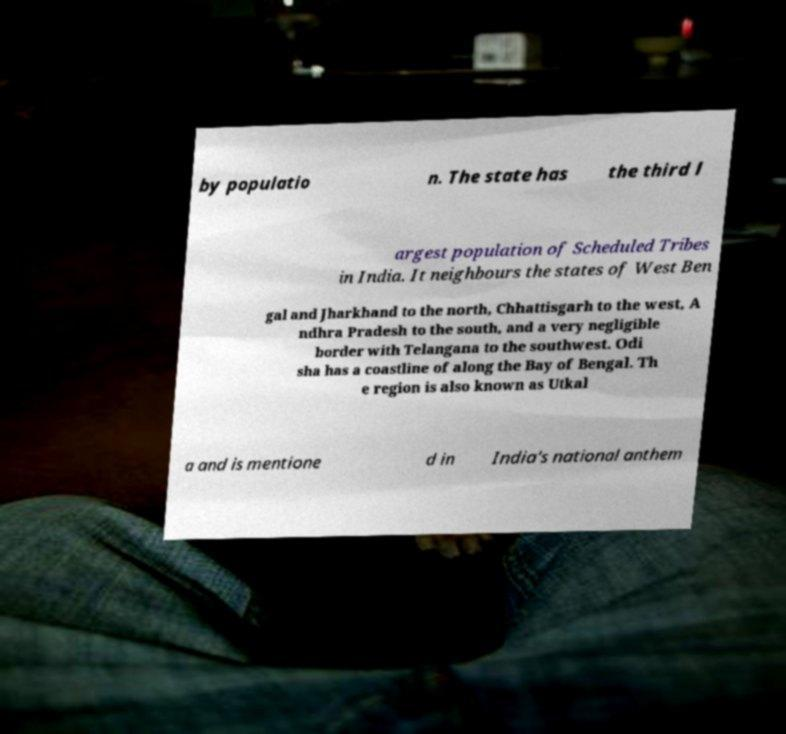Could you assist in decoding the text presented in this image and type it out clearly? by populatio n. The state has the third l argest population of Scheduled Tribes in India. It neighbours the states of West Ben gal and Jharkhand to the north, Chhattisgarh to the west, A ndhra Pradesh to the south, and a very negligible border with Telangana to the southwest. Odi sha has a coastline of along the Bay of Bengal. Th e region is also known as Utkal a and is mentione d in India's national anthem 